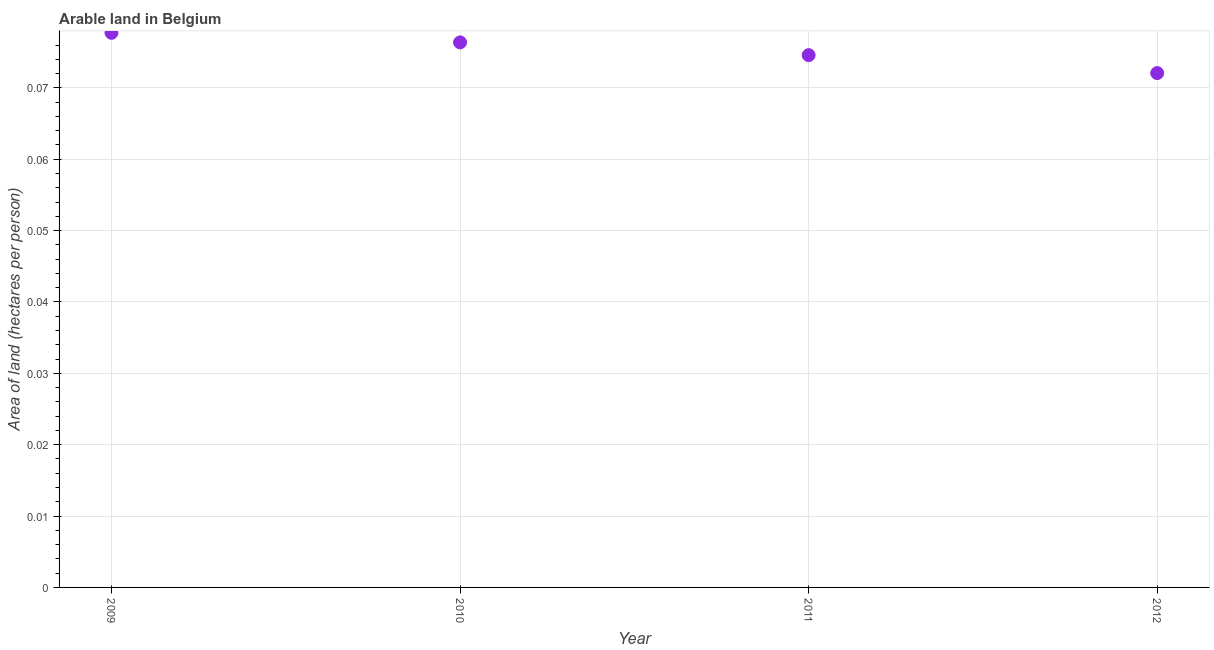What is the area of arable land in 2009?
Your answer should be compact. 0.08. Across all years, what is the maximum area of arable land?
Offer a terse response. 0.08. Across all years, what is the minimum area of arable land?
Make the answer very short. 0.07. In which year was the area of arable land maximum?
Your response must be concise. 2009. What is the sum of the area of arable land?
Offer a terse response. 0.3. What is the difference between the area of arable land in 2009 and 2011?
Your response must be concise. 0. What is the average area of arable land per year?
Provide a short and direct response. 0.08. What is the median area of arable land?
Give a very brief answer. 0.08. Do a majority of the years between 2010 and 2012 (inclusive) have area of arable land greater than 0.016 hectares per person?
Ensure brevity in your answer.  Yes. What is the ratio of the area of arable land in 2010 to that in 2012?
Your answer should be compact. 1.06. What is the difference between the highest and the second highest area of arable land?
Your answer should be very brief. 0. Is the sum of the area of arable land in 2010 and 2012 greater than the maximum area of arable land across all years?
Provide a short and direct response. Yes. What is the difference between the highest and the lowest area of arable land?
Provide a short and direct response. 0.01. How many years are there in the graph?
Your answer should be very brief. 4. Are the values on the major ticks of Y-axis written in scientific E-notation?
Your answer should be compact. No. Does the graph contain grids?
Offer a terse response. Yes. What is the title of the graph?
Keep it short and to the point. Arable land in Belgium. What is the label or title of the X-axis?
Your answer should be very brief. Year. What is the label or title of the Y-axis?
Your answer should be very brief. Area of land (hectares per person). What is the Area of land (hectares per person) in 2009?
Your response must be concise. 0.08. What is the Area of land (hectares per person) in 2010?
Provide a succinct answer. 0.08. What is the Area of land (hectares per person) in 2011?
Your response must be concise. 0.07. What is the Area of land (hectares per person) in 2012?
Ensure brevity in your answer.  0.07. What is the difference between the Area of land (hectares per person) in 2009 and 2010?
Provide a succinct answer. 0. What is the difference between the Area of land (hectares per person) in 2009 and 2011?
Ensure brevity in your answer.  0. What is the difference between the Area of land (hectares per person) in 2009 and 2012?
Your answer should be very brief. 0.01. What is the difference between the Area of land (hectares per person) in 2010 and 2011?
Ensure brevity in your answer.  0. What is the difference between the Area of land (hectares per person) in 2010 and 2012?
Make the answer very short. 0. What is the difference between the Area of land (hectares per person) in 2011 and 2012?
Keep it short and to the point. 0. What is the ratio of the Area of land (hectares per person) in 2009 to that in 2011?
Keep it short and to the point. 1.04. What is the ratio of the Area of land (hectares per person) in 2009 to that in 2012?
Keep it short and to the point. 1.08. What is the ratio of the Area of land (hectares per person) in 2010 to that in 2011?
Provide a succinct answer. 1.02. What is the ratio of the Area of land (hectares per person) in 2010 to that in 2012?
Provide a succinct answer. 1.06. What is the ratio of the Area of land (hectares per person) in 2011 to that in 2012?
Your answer should be very brief. 1.03. 